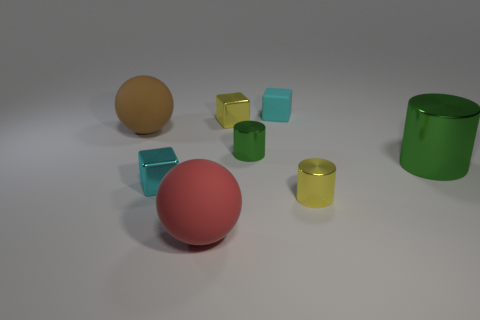Are there any patterns or symmetry in how the objects are arranged? The arrangement of objects in the image lacks a clear pattern or symmetry. The items are placed at varying distances from each other and do not conform to a grid or any symmetric layout. This randomness provides an organic feel to the composition, highlighting the individual characteristics of each object. 